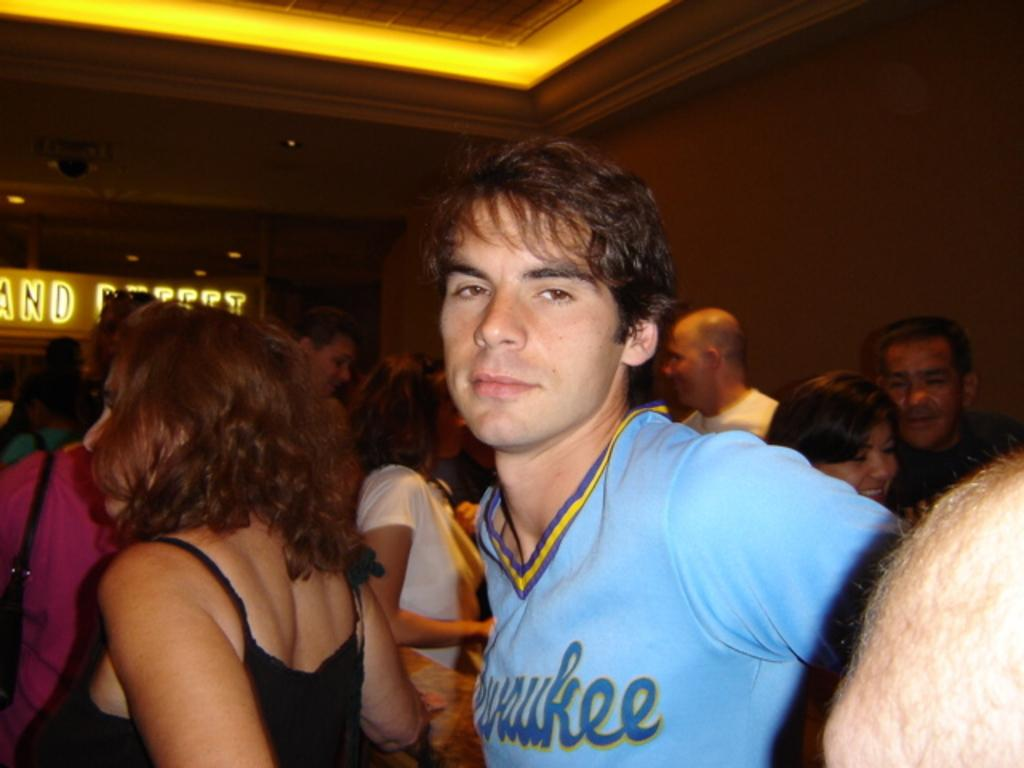What can be seen in the image? There are people standing in the image. What is visible in the background of the image? There is a wall in the background of the image. What is above the people in the image? There is a ceiling visible in the image. What provides illumination in the image? There are lights in the image. Are there any yaks present in the image? No, there are no yaks present in the image. Can you tell me which island the people are standing on in the image? The image does not provide any information about an island, so it cannot be determined from the image. 